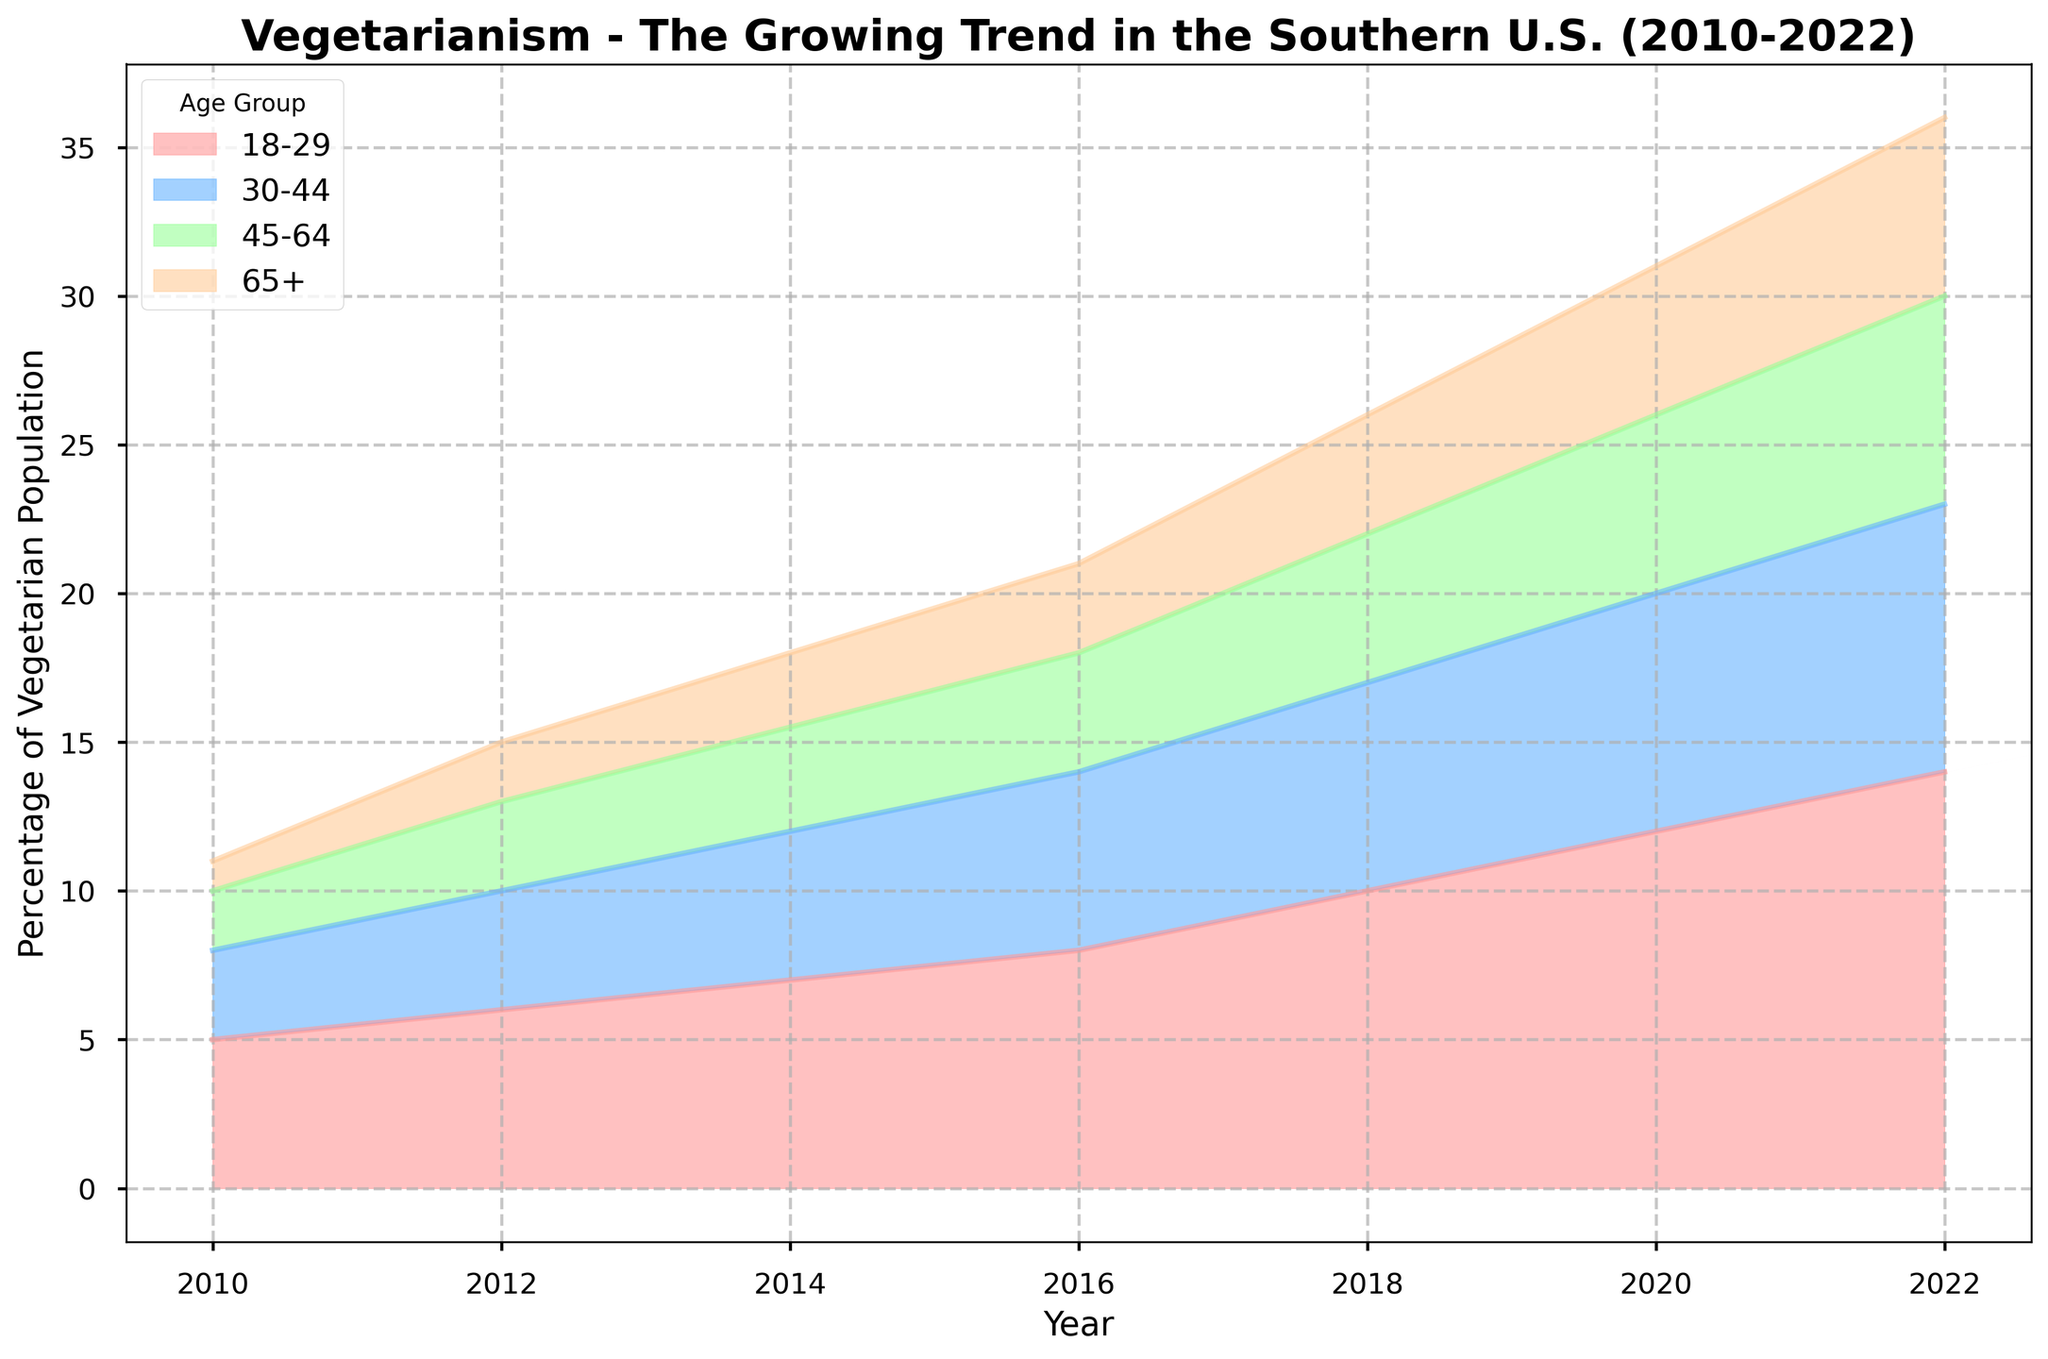What age group had the highest percentage of vegetarians in 2022? From the area chart, observe the highest peak for the year 2022 which corresponds to the age group 18-29.
Answer: 18-29 How did the vegetarian percentage change for the 30-44 age group from 2010 to 2022? In 2010, the percentage for the 30-44 age group was 3%. By 2022, it increased to 9%. The change is 9% - 3%.
Answer: Increased by 6% Comparing 2010 and 2020, which age group saw the largest increase in vegetarian percentage? Check the difference for each age group between 2010 and 2020: 
- 18-29: 12% - 5% = 7%
- 30-44: 8% - 3% = 5%
- 45-64: 6% - 2% = 4%
- 65+: 5% - 1% = 4%
The largest increase is for 18-29.
Answer: 18-29 What was the percentage increase in vegetarians for the 45-64 age group from 2016 to 2022? In 2016, the percentage for 45-64 was 4%. By 2022, it increased to 7%. The percentage increase is ((7% - 4%) / 4%) * 100%.
Answer: 75% Which age group had the smallest increase in vegetarian percentage from 2010 to 2022? Calculate the increases for all age groups:
- 18-29: 14% - 5% = 9%
- 30-44: 9% - 3% = 6%
- 45-64: 7% - 2% = 5%
- 65+: 6% - 1% = 5%
Both 45-64 and 65+ had the smallest increase at 5%.
Answer: 45-64 and 65+ How does the vegetarian percentage for 18-29 in the year 2014 compare to 65+ in the year 2022? In 2014, the 18-29 group had 7%. In 2022, the 65+ group had 6%. 7% is greater than 6%.
Answer: 18-29 > 65+ Which year had the highest combined vegetarian percentage across all age groups? Sum the percentages for all groups per year:
- 2010: 5%+3%+2%+1% = 11%
- 2012: 6%+4%+3%+2% = 15%
- 2014: 7%+5%+3.5%+2.5% = 18%
- 2016: 8%+6%+4%+3% = 21%
- 2018: 10%+7%+5%+4% = 26%
- 2020: 12%+8%+6%+5% = 31%
- 2022: 14%+9%+7%+6% = 36%
The highest combined percentage is in 2022.
Answer: 2022 What pattern can you observe in vegetarianism trends across different age groups from 2010 to 2022? Generally, there's a steady increase across all age groups over the years. The younger age groups (18-29 and 30-44) have the highest percentages and the steepest increases compared to older groups.
Answer: Steady increase, higher in younger age groups Which age group's vegetarian percentage remained below 5% the longest? Review the percentages for each age group across the years. The 65+ group's percentage stayed below 5% until 2018 (reached 4% in 2018, 5% in 2020).
Answer: 65+ Between which consecutive years did the 18-29 age group experience the largest jump in vegetarian percentage? Calculate the increases for 18-29 across each pair of consecutive years:
- 2010 to 2012: 6% - 5% = 1%
- 2012 to 2014: 7% - 6% = 1%
- 2014 to 2016: 8% - 7% = 1%
- 2016 to 2018: 10% - 8% = 2%
- 2018 to 2020: 12% - 10% = 2%
- 2020 to 2022: 14% - 12% = 2%
The largest increase happened between consecutive years 2016 to 2018, 2018 to 2020, and 2020 to 2022, all with a 2% increase.
Answer: 2016-2018, 2018-2020, 2020-2022 